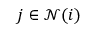<formula> <loc_0><loc_0><loc_500><loc_500>j \in \mathcal { N } ( i )</formula> 